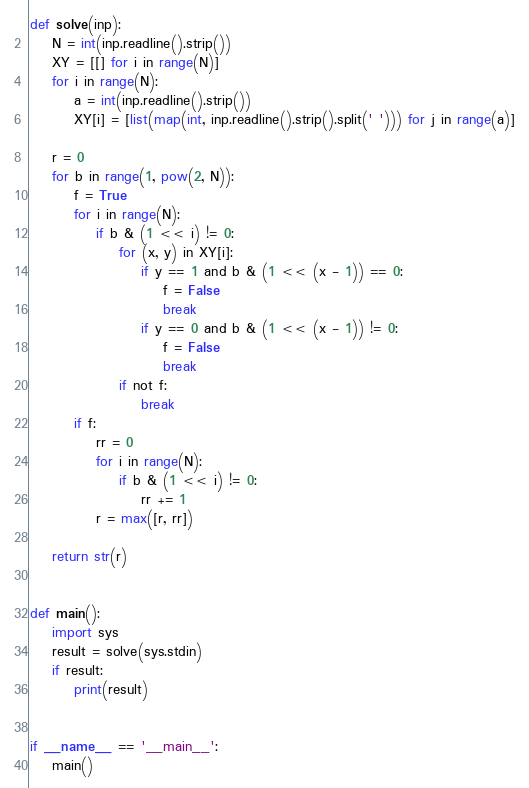<code> <loc_0><loc_0><loc_500><loc_500><_Python_>def solve(inp):
    N = int(inp.readline().strip())
    XY = [[] for i in range(N)]
    for i in range(N):
        a = int(inp.readline().strip())
        XY[i] = [list(map(int, inp.readline().strip().split(' '))) for j in range(a)]

    r = 0
    for b in range(1, pow(2, N)):
        f = True
        for i in range(N):
            if b & (1 << i) != 0:
                for (x, y) in XY[i]:
                    if y == 1 and b & (1 << (x - 1)) == 0:
                        f = False
                        break
                    if y == 0 and b & (1 << (x - 1)) != 0:
                        f = False
                        break
                if not f:
                    break
        if f:
            rr = 0
            for i in range(N):
                if b & (1 << i) != 0:
                    rr += 1
            r = max([r, rr])

    return str(r)


def main():
    import sys
    result = solve(sys.stdin)
    if result:
        print(result)


if __name__ == '__main__':
    main()
</code> 